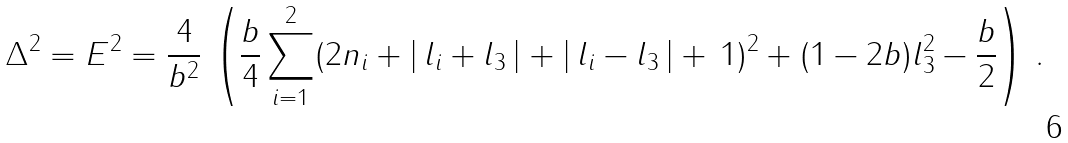<formula> <loc_0><loc_0><loc_500><loc_500>\Delta ^ { 2 } = E ^ { 2 } = \frac { 4 } { b ^ { 2 } } \, \left ( \frac { b } { 4 } \sum _ { i = 1 } ^ { 2 } ( 2 n _ { i } + | \, l _ { i } + l _ { 3 } \, | + | \, l _ { i } - l _ { 3 } \, | + \, 1 ) ^ { 2 } + ( 1 - 2 b ) l _ { 3 } ^ { 2 } - \frac { b } { 2 } \right ) \, .</formula> 